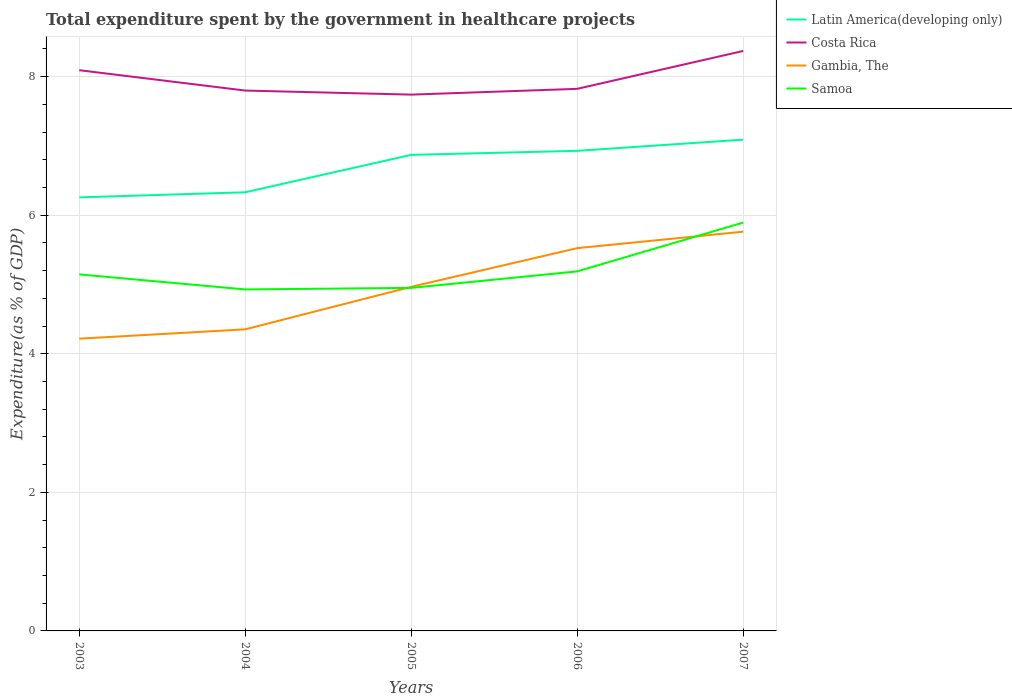Does the line corresponding to Samoa intersect with the line corresponding to Costa Rica?
Provide a succinct answer. No. Across all years, what is the maximum total expenditure spent by the government in healthcare projects in Latin America(developing only)?
Offer a terse response. 6.26. What is the total total expenditure spent by the government in healthcare projects in Gambia, The in the graph?
Keep it short and to the point. -1.54. What is the difference between the highest and the second highest total expenditure spent by the government in healthcare projects in Costa Rica?
Your answer should be compact. 0.63. Is the total expenditure spent by the government in healthcare projects in Gambia, The strictly greater than the total expenditure spent by the government in healthcare projects in Latin America(developing only) over the years?
Provide a succinct answer. Yes. How many lines are there?
Your response must be concise. 4. What is the difference between two consecutive major ticks on the Y-axis?
Ensure brevity in your answer.  2. Does the graph contain any zero values?
Keep it short and to the point. No. How many legend labels are there?
Keep it short and to the point. 4. How are the legend labels stacked?
Your response must be concise. Vertical. What is the title of the graph?
Offer a very short reply. Total expenditure spent by the government in healthcare projects. What is the label or title of the X-axis?
Offer a very short reply. Years. What is the label or title of the Y-axis?
Offer a terse response. Expenditure(as % of GDP). What is the Expenditure(as % of GDP) of Latin America(developing only) in 2003?
Make the answer very short. 6.26. What is the Expenditure(as % of GDP) in Costa Rica in 2003?
Provide a succinct answer. 8.09. What is the Expenditure(as % of GDP) of Gambia, The in 2003?
Ensure brevity in your answer.  4.22. What is the Expenditure(as % of GDP) in Samoa in 2003?
Keep it short and to the point. 5.15. What is the Expenditure(as % of GDP) of Latin America(developing only) in 2004?
Provide a succinct answer. 6.33. What is the Expenditure(as % of GDP) of Costa Rica in 2004?
Offer a very short reply. 7.8. What is the Expenditure(as % of GDP) in Gambia, The in 2004?
Your answer should be very brief. 4.35. What is the Expenditure(as % of GDP) of Samoa in 2004?
Keep it short and to the point. 4.93. What is the Expenditure(as % of GDP) in Latin America(developing only) in 2005?
Your answer should be compact. 6.87. What is the Expenditure(as % of GDP) in Costa Rica in 2005?
Offer a very short reply. 7.74. What is the Expenditure(as % of GDP) of Gambia, The in 2005?
Provide a succinct answer. 4.97. What is the Expenditure(as % of GDP) of Samoa in 2005?
Keep it short and to the point. 4.95. What is the Expenditure(as % of GDP) of Latin America(developing only) in 2006?
Offer a terse response. 6.93. What is the Expenditure(as % of GDP) in Costa Rica in 2006?
Offer a terse response. 7.82. What is the Expenditure(as % of GDP) in Gambia, The in 2006?
Offer a terse response. 5.52. What is the Expenditure(as % of GDP) in Samoa in 2006?
Your answer should be compact. 5.19. What is the Expenditure(as % of GDP) in Latin America(developing only) in 2007?
Keep it short and to the point. 7.09. What is the Expenditure(as % of GDP) in Costa Rica in 2007?
Your response must be concise. 8.37. What is the Expenditure(as % of GDP) in Gambia, The in 2007?
Offer a very short reply. 5.76. What is the Expenditure(as % of GDP) in Samoa in 2007?
Offer a terse response. 5.89. Across all years, what is the maximum Expenditure(as % of GDP) of Latin America(developing only)?
Make the answer very short. 7.09. Across all years, what is the maximum Expenditure(as % of GDP) of Costa Rica?
Offer a very short reply. 8.37. Across all years, what is the maximum Expenditure(as % of GDP) in Gambia, The?
Offer a terse response. 5.76. Across all years, what is the maximum Expenditure(as % of GDP) of Samoa?
Your response must be concise. 5.89. Across all years, what is the minimum Expenditure(as % of GDP) in Latin America(developing only)?
Your answer should be compact. 6.26. Across all years, what is the minimum Expenditure(as % of GDP) of Costa Rica?
Provide a short and direct response. 7.74. Across all years, what is the minimum Expenditure(as % of GDP) of Gambia, The?
Offer a very short reply. 4.22. Across all years, what is the minimum Expenditure(as % of GDP) in Samoa?
Make the answer very short. 4.93. What is the total Expenditure(as % of GDP) of Latin America(developing only) in the graph?
Offer a very short reply. 33.48. What is the total Expenditure(as % of GDP) in Costa Rica in the graph?
Your answer should be very brief. 39.82. What is the total Expenditure(as % of GDP) in Gambia, The in the graph?
Make the answer very short. 24.82. What is the total Expenditure(as % of GDP) of Samoa in the graph?
Offer a very short reply. 26.11. What is the difference between the Expenditure(as % of GDP) of Latin America(developing only) in 2003 and that in 2004?
Offer a terse response. -0.07. What is the difference between the Expenditure(as % of GDP) of Costa Rica in 2003 and that in 2004?
Your answer should be compact. 0.29. What is the difference between the Expenditure(as % of GDP) in Gambia, The in 2003 and that in 2004?
Give a very brief answer. -0.13. What is the difference between the Expenditure(as % of GDP) in Samoa in 2003 and that in 2004?
Your answer should be compact. 0.22. What is the difference between the Expenditure(as % of GDP) of Latin America(developing only) in 2003 and that in 2005?
Your answer should be very brief. -0.61. What is the difference between the Expenditure(as % of GDP) of Costa Rica in 2003 and that in 2005?
Your response must be concise. 0.35. What is the difference between the Expenditure(as % of GDP) in Gambia, The in 2003 and that in 2005?
Ensure brevity in your answer.  -0.75. What is the difference between the Expenditure(as % of GDP) in Samoa in 2003 and that in 2005?
Your answer should be very brief. 0.19. What is the difference between the Expenditure(as % of GDP) of Latin America(developing only) in 2003 and that in 2006?
Your answer should be compact. -0.67. What is the difference between the Expenditure(as % of GDP) of Costa Rica in 2003 and that in 2006?
Your answer should be compact. 0.27. What is the difference between the Expenditure(as % of GDP) in Gambia, The in 2003 and that in 2006?
Offer a very short reply. -1.31. What is the difference between the Expenditure(as % of GDP) in Samoa in 2003 and that in 2006?
Your answer should be compact. -0.04. What is the difference between the Expenditure(as % of GDP) of Latin America(developing only) in 2003 and that in 2007?
Provide a succinct answer. -0.83. What is the difference between the Expenditure(as % of GDP) of Costa Rica in 2003 and that in 2007?
Ensure brevity in your answer.  -0.28. What is the difference between the Expenditure(as % of GDP) in Gambia, The in 2003 and that in 2007?
Offer a very short reply. -1.54. What is the difference between the Expenditure(as % of GDP) of Samoa in 2003 and that in 2007?
Give a very brief answer. -0.75. What is the difference between the Expenditure(as % of GDP) of Latin America(developing only) in 2004 and that in 2005?
Provide a short and direct response. -0.54. What is the difference between the Expenditure(as % of GDP) in Costa Rica in 2004 and that in 2005?
Your response must be concise. 0.06. What is the difference between the Expenditure(as % of GDP) in Gambia, The in 2004 and that in 2005?
Offer a very short reply. -0.61. What is the difference between the Expenditure(as % of GDP) in Samoa in 2004 and that in 2005?
Make the answer very short. -0.02. What is the difference between the Expenditure(as % of GDP) of Latin America(developing only) in 2004 and that in 2006?
Your answer should be very brief. -0.6. What is the difference between the Expenditure(as % of GDP) of Costa Rica in 2004 and that in 2006?
Give a very brief answer. -0.02. What is the difference between the Expenditure(as % of GDP) of Gambia, The in 2004 and that in 2006?
Keep it short and to the point. -1.17. What is the difference between the Expenditure(as % of GDP) of Samoa in 2004 and that in 2006?
Your response must be concise. -0.26. What is the difference between the Expenditure(as % of GDP) of Latin America(developing only) in 2004 and that in 2007?
Give a very brief answer. -0.76. What is the difference between the Expenditure(as % of GDP) in Costa Rica in 2004 and that in 2007?
Provide a short and direct response. -0.57. What is the difference between the Expenditure(as % of GDP) in Gambia, The in 2004 and that in 2007?
Offer a terse response. -1.41. What is the difference between the Expenditure(as % of GDP) in Samoa in 2004 and that in 2007?
Make the answer very short. -0.96. What is the difference between the Expenditure(as % of GDP) of Latin America(developing only) in 2005 and that in 2006?
Your answer should be very brief. -0.06. What is the difference between the Expenditure(as % of GDP) in Costa Rica in 2005 and that in 2006?
Your answer should be very brief. -0.08. What is the difference between the Expenditure(as % of GDP) of Gambia, The in 2005 and that in 2006?
Provide a short and direct response. -0.56. What is the difference between the Expenditure(as % of GDP) of Samoa in 2005 and that in 2006?
Make the answer very short. -0.24. What is the difference between the Expenditure(as % of GDP) of Latin America(developing only) in 2005 and that in 2007?
Your response must be concise. -0.22. What is the difference between the Expenditure(as % of GDP) in Costa Rica in 2005 and that in 2007?
Offer a very short reply. -0.63. What is the difference between the Expenditure(as % of GDP) of Gambia, The in 2005 and that in 2007?
Your answer should be very brief. -0.8. What is the difference between the Expenditure(as % of GDP) of Samoa in 2005 and that in 2007?
Offer a terse response. -0.94. What is the difference between the Expenditure(as % of GDP) of Latin America(developing only) in 2006 and that in 2007?
Offer a terse response. -0.16. What is the difference between the Expenditure(as % of GDP) of Costa Rica in 2006 and that in 2007?
Your response must be concise. -0.55. What is the difference between the Expenditure(as % of GDP) in Gambia, The in 2006 and that in 2007?
Ensure brevity in your answer.  -0.24. What is the difference between the Expenditure(as % of GDP) in Samoa in 2006 and that in 2007?
Ensure brevity in your answer.  -0.7. What is the difference between the Expenditure(as % of GDP) of Latin America(developing only) in 2003 and the Expenditure(as % of GDP) of Costa Rica in 2004?
Your answer should be compact. -1.54. What is the difference between the Expenditure(as % of GDP) in Latin America(developing only) in 2003 and the Expenditure(as % of GDP) in Gambia, The in 2004?
Your answer should be compact. 1.9. What is the difference between the Expenditure(as % of GDP) in Latin America(developing only) in 2003 and the Expenditure(as % of GDP) in Samoa in 2004?
Make the answer very short. 1.33. What is the difference between the Expenditure(as % of GDP) in Costa Rica in 2003 and the Expenditure(as % of GDP) in Gambia, The in 2004?
Keep it short and to the point. 3.74. What is the difference between the Expenditure(as % of GDP) in Costa Rica in 2003 and the Expenditure(as % of GDP) in Samoa in 2004?
Your answer should be very brief. 3.16. What is the difference between the Expenditure(as % of GDP) in Gambia, The in 2003 and the Expenditure(as % of GDP) in Samoa in 2004?
Keep it short and to the point. -0.71. What is the difference between the Expenditure(as % of GDP) in Latin America(developing only) in 2003 and the Expenditure(as % of GDP) in Costa Rica in 2005?
Offer a very short reply. -1.48. What is the difference between the Expenditure(as % of GDP) of Latin America(developing only) in 2003 and the Expenditure(as % of GDP) of Gambia, The in 2005?
Make the answer very short. 1.29. What is the difference between the Expenditure(as % of GDP) of Latin America(developing only) in 2003 and the Expenditure(as % of GDP) of Samoa in 2005?
Your answer should be compact. 1.31. What is the difference between the Expenditure(as % of GDP) of Costa Rica in 2003 and the Expenditure(as % of GDP) of Gambia, The in 2005?
Make the answer very short. 3.13. What is the difference between the Expenditure(as % of GDP) in Costa Rica in 2003 and the Expenditure(as % of GDP) in Samoa in 2005?
Keep it short and to the point. 3.14. What is the difference between the Expenditure(as % of GDP) in Gambia, The in 2003 and the Expenditure(as % of GDP) in Samoa in 2005?
Provide a short and direct response. -0.73. What is the difference between the Expenditure(as % of GDP) in Latin America(developing only) in 2003 and the Expenditure(as % of GDP) in Costa Rica in 2006?
Give a very brief answer. -1.57. What is the difference between the Expenditure(as % of GDP) of Latin America(developing only) in 2003 and the Expenditure(as % of GDP) of Gambia, The in 2006?
Your answer should be compact. 0.73. What is the difference between the Expenditure(as % of GDP) of Latin America(developing only) in 2003 and the Expenditure(as % of GDP) of Samoa in 2006?
Your answer should be very brief. 1.07. What is the difference between the Expenditure(as % of GDP) in Costa Rica in 2003 and the Expenditure(as % of GDP) in Gambia, The in 2006?
Your answer should be very brief. 2.57. What is the difference between the Expenditure(as % of GDP) in Costa Rica in 2003 and the Expenditure(as % of GDP) in Samoa in 2006?
Your answer should be very brief. 2.9. What is the difference between the Expenditure(as % of GDP) of Gambia, The in 2003 and the Expenditure(as % of GDP) of Samoa in 2006?
Your answer should be very brief. -0.97. What is the difference between the Expenditure(as % of GDP) in Latin America(developing only) in 2003 and the Expenditure(as % of GDP) in Costa Rica in 2007?
Provide a short and direct response. -2.11. What is the difference between the Expenditure(as % of GDP) in Latin America(developing only) in 2003 and the Expenditure(as % of GDP) in Gambia, The in 2007?
Your response must be concise. 0.5. What is the difference between the Expenditure(as % of GDP) in Latin America(developing only) in 2003 and the Expenditure(as % of GDP) in Samoa in 2007?
Your response must be concise. 0.36. What is the difference between the Expenditure(as % of GDP) in Costa Rica in 2003 and the Expenditure(as % of GDP) in Gambia, The in 2007?
Your answer should be very brief. 2.33. What is the difference between the Expenditure(as % of GDP) of Costa Rica in 2003 and the Expenditure(as % of GDP) of Samoa in 2007?
Offer a terse response. 2.2. What is the difference between the Expenditure(as % of GDP) in Gambia, The in 2003 and the Expenditure(as % of GDP) in Samoa in 2007?
Ensure brevity in your answer.  -1.68. What is the difference between the Expenditure(as % of GDP) of Latin America(developing only) in 2004 and the Expenditure(as % of GDP) of Costa Rica in 2005?
Ensure brevity in your answer.  -1.41. What is the difference between the Expenditure(as % of GDP) in Latin America(developing only) in 2004 and the Expenditure(as % of GDP) in Gambia, The in 2005?
Your answer should be very brief. 1.36. What is the difference between the Expenditure(as % of GDP) of Latin America(developing only) in 2004 and the Expenditure(as % of GDP) of Samoa in 2005?
Give a very brief answer. 1.38. What is the difference between the Expenditure(as % of GDP) in Costa Rica in 2004 and the Expenditure(as % of GDP) in Gambia, The in 2005?
Provide a succinct answer. 2.83. What is the difference between the Expenditure(as % of GDP) of Costa Rica in 2004 and the Expenditure(as % of GDP) of Samoa in 2005?
Ensure brevity in your answer.  2.85. What is the difference between the Expenditure(as % of GDP) in Gambia, The in 2004 and the Expenditure(as % of GDP) in Samoa in 2005?
Offer a terse response. -0.6. What is the difference between the Expenditure(as % of GDP) of Latin America(developing only) in 2004 and the Expenditure(as % of GDP) of Costa Rica in 2006?
Your answer should be very brief. -1.49. What is the difference between the Expenditure(as % of GDP) of Latin America(developing only) in 2004 and the Expenditure(as % of GDP) of Gambia, The in 2006?
Offer a very short reply. 0.81. What is the difference between the Expenditure(as % of GDP) in Latin America(developing only) in 2004 and the Expenditure(as % of GDP) in Samoa in 2006?
Your answer should be compact. 1.14. What is the difference between the Expenditure(as % of GDP) of Costa Rica in 2004 and the Expenditure(as % of GDP) of Gambia, The in 2006?
Provide a short and direct response. 2.27. What is the difference between the Expenditure(as % of GDP) in Costa Rica in 2004 and the Expenditure(as % of GDP) in Samoa in 2006?
Offer a very short reply. 2.61. What is the difference between the Expenditure(as % of GDP) in Gambia, The in 2004 and the Expenditure(as % of GDP) in Samoa in 2006?
Provide a short and direct response. -0.84. What is the difference between the Expenditure(as % of GDP) of Latin America(developing only) in 2004 and the Expenditure(as % of GDP) of Costa Rica in 2007?
Ensure brevity in your answer.  -2.04. What is the difference between the Expenditure(as % of GDP) of Latin America(developing only) in 2004 and the Expenditure(as % of GDP) of Gambia, The in 2007?
Offer a terse response. 0.57. What is the difference between the Expenditure(as % of GDP) in Latin America(developing only) in 2004 and the Expenditure(as % of GDP) in Samoa in 2007?
Your answer should be compact. 0.44. What is the difference between the Expenditure(as % of GDP) in Costa Rica in 2004 and the Expenditure(as % of GDP) in Gambia, The in 2007?
Your answer should be compact. 2.04. What is the difference between the Expenditure(as % of GDP) in Costa Rica in 2004 and the Expenditure(as % of GDP) in Samoa in 2007?
Your answer should be very brief. 1.91. What is the difference between the Expenditure(as % of GDP) of Gambia, The in 2004 and the Expenditure(as % of GDP) of Samoa in 2007?
Ensure brevity in your answer.  -1.54. What is the difference between the Expenditure(as % of GDP) of Latin America(developing only) in 2005 and the Expenditure(as % of GDP) of Costa Rica in 2006?
Offer a very short reply. -0.95. What is the difference between the Expenditure(as % of GDP) in Latin America(developing only) in 2005 and the Expenditure(as % of GDP) in Gambia, The in 2006?
Offer a very short reply. 1.35. What is the difference between the Expenditure(as % of GDP) of Latin America(developing only) in 2005 and the Expenditure(as % of GDP) of Samoa in 2006?
Your response must be concise. 1.68. What is the difference between the Expenditure(as % of GDP) of Costa Rica in 2005 and the Expenditure(as % of GDP) of Gambia, The in 2006?
Give a very brief answer. 2.22. What is the difference between the Expenditure(as % of GDP) of Costa Rica in 2005 and the Expenditure(as % of GDP) of Samoa in 2006?
Offer a very short reply. 2.55. What is the difference between the Expenditure(as % of GDP) in Gambia, The in 2005 and the Expenditure(as % of GDP) in Samoa in 2006?
Your answer should be very brief. -0.22. What is the difference between the Expenditure(as % of GDP) in Latin America(developing only) in 2005 and the Expenditure(as % of GDP) in Costa Rica in 2007?
Keep it short and to the point. -1.5. What is the difference between the Expenditure(as % of GDP) of Latin America(developing only) in 2005 and the Expenditure(as % of GDP) of Gambia, The in 2007?
Your answer should be very brief. 1.11. What is the difference between the Expenditure(as % of GDP) of Latin America(developing only) in 2005 and the Expenditure(as % of GDP) of Samoa in 2007?
Your response must be concise. 0.98. What is the difference between the Expenditure(as % of GDP) of Costa Rica in 2005 and the Expenditure(as % of GDP) of Gambia, The in 2007?
Give a very brief answer. 1.98. What is the difference between the Expenditure(as % of GDP) of Costa Rica in 2005 and the Expenditure(as % of GDP) of Samoa in 2007?
Make the answer very short. 1.85. What is the difference between the Expenditure(as % of GDP) of Gambia, The in 2005 and the Expenditure(as % of GDP) of Samoa in 2007?
Ensure brevity in your answer.  -0.93. What is the difference between the Expenditure(as % of GDP) of Latin America(developing only) in 2006 and the Expenditure(as % of GDP) of Costa Rica in 2007?
Offer a terse response. -1.44. What is the difference between the Expenditure(as % of GDP) in Latin America(developing only) in 2006 and the Expenditure(as % of GDP) in Samoa in 2007?
Keep it short and to the point. 1.04. What is the difference between the Expenditure(as % of GDP) in Costa Rica in 2006 and the Expenditure(as % of GDP) in Gambia, The in 2007?
Your answer should be compact. 2.06. What is the difference between the Expenditure(as % of GDP) in Costa Rica in 2006 and the Expenditure(as % of GDP) in Samoa in 2007?
Give a very brief answer. 1.93. What is the difference between the Expenditure(as % of GDP) in Gambia, The in 2006 and the Expenditure(as % of GDP) in Samoa in 2007?
Ensure brevity in your answer.  -0.37. What is the average Expenditure(as % of GDP) in Latin America(developing only) per year?
Give a very brief answer. 6.7. What is the average Expenditure(as % of GDP) in Costa Rica per year?
Provide a short and direct response. 7.96. What is the average Expenditure(as % of GDP) of Gambia, The per year?
Offer a very short reply. 4.96. What is the average Expenditure(as % of GDP) in Samoa per year?
Keep it short and to the point. 5.22. In the year 2003, what is the difference between the Expenditure(as % of GDP) of Latin America(developing only) and Expenditure(as % of GDP) of Costa Rica?
Make the answer very short. -1.84. In the year 2003, what is the difference between the Expenditure(as % of GDP) of Latin America(developing only) and Expenditure(as % of GDP) of Gambia, The?
Keep it short and to the point. 2.04. In the year 2003, what is the difference between the Expenditure(as % of GDP) of Latin America(developing only) and Expenditure(as % of GDP) of Samoa?
Offer a very short reply. 1.11. In the year 2003, what is the difference between the Expenditure(as % of GDP) of Costa Rica and Expenditure(as % of GDP) of Gambia, The?
Your answer should be compact. 3.87. In the year 2003, what is the difference between the Expenditure(as % of GDP) in Costa Rica and Expenditure(as % of GDP) in Samoa?
Your answer should be very brief. 2.95. In the year 2003, what is the difference between the Expenditure(as % of GDP) in Gambia, The and Expenditure(as % of GDP) in Samoa?
Give a very brief answer. -0.93. In the year 2004, what is the difference between the Expenditure(as % of GDP) in Latin America(developing only) and Expenditure(as % of GDP) in Costa Rica?
Provide a short and direct response. -1.47. In the year 2004, what is the difference between the Expenditure(as % of GDP) of Latin America(developing only) and Expenditure(as % of GDP) of Gambia, The?
Make the answer very short. 1.98. In the year 2004, what is the difference between the Expenditure(as % of GDP) in Latin America(developing only) and Expenditure(as % of GDP) in Samoa?
Provide a short and direct response. 1.4. In the year 2004, what is the difference between the Expenditure(as % of GDP) in Costa Rica and Expenditure(as % of GDP) in Gambia, The?
Offer a very short reply. 3.45. In the year 2004, what is the difference between the Expenditure(as % of GDP) in Costa Rica and Expenditure(as % of GDP) in Samoa?
Keep it short and to the point. 2.87. In the year 2004, what is the difference between the Expenditure(as % of GDP) of Gambia, The and Expenditure(as % of GDP) of Samoa?
Keep it short and to the point. -0.58. In the year 2005, what is the difference between the Expenditure(as % of GDP) of Latin America(developing only) and Expenditure(as % of GDP) of Costa Rica?
Provide a short and direct response. -0.87. In the year 2005, what is the difference between the Expenditure(as % of GDP) in Latin America(developing only) and Expenditure(as % of GDP) in Gambia, The?
Ensure brevity in your answer.  1.9. In the year 2005, what is the difference between the Expenditure(as % of GDP) of Latin America(developing only) and Expenditure(as % of GDP) of Samoa?
Keep it short and to the point. 1.92. In the year 2005, what is the difference between the Expenditure(as % of GDP) of Costa Rica and Expenditure(as % of GDP) of Gambia, The?
Your answer should be compact. 2.77. In the year 2005, what is the difference between the Expenditure(as % of GDP) of Costa Rica and Expenditure(as % of GDP) of Samoa?
Your answer should be compact. 2.79. In the year 2005, what is the difference between the Expenditure(as % of GDP) in Gambia, The and Expenditure(as % of GDP) in Samoa?
Your answer should be compact. 0.02. In the year 2006, what is the difference between the Expenditure(as % of GDP) of Latin America(developing only) and Expenditure(as % of GDP) of Costa Rica?
Your response must be concise. -0.89. In the year 2006, what is the difference between the Expenditure(as % of GDP) of Latin America(developing only) and Expenditure(as % of GDP) of Gambia, The?
Offer a terse response. 1.4. In the year 2006, what is the difference between the Expenditure(as % of GDP) of Latin America(developing only) and Expenditure(as % of GDP) of Samoa?
Provide a succinct answer. 1.74. In the year 2006, what is the difference between the Expenditure(as % of GDP) in Costa Rica and Expenditure(as % of GDP) in Gambia, The?
Provide a succinct answer. 2.3. In the year 2006, what is the difference between the Expenditure(as % of GDP) of Costa Rica and Expenditure(as % of GDP) of Samoa?
Provide a short and direct response. 2.63. In the year 2006, what is the difference between the Expenditure(as % of GDP) in Gambia, The and Expenditure(as % of GDP) in Samoa?
Provide a succinct answer. 0.34. In the year 2007, what is the difference between the Expenditure(as % of GDP) in Latin America(developing only) and Expenditure(as % of GDP) in Costa Rica?
Your response must be concise. -1.28. In the year 2007, what is the difference between the Expenditure(as % of GDP) in Latin America(developing only) and Expenditure(as % of GDP) in Gambia, The?
Keep it short and to the point. 1.33. In the year 2007, what is the difference between the Expenditure(as % of GDP) of Latin America(developing only) and Expenditure(as % of GDP) of Samoa?
Make the answer very short. 1.2. In the year 2007, what is the difference between the Expenditure(as % of GDP) in Costa Rica and Expenditure(as % of GDP) in Gambia, The?
Give a very brief answer. 2.61. In the year 2007, what is the difference between the Expenditure(as % of GDP) of Costa Rica and Expenditure(as % of GDP) of Samoa?
Make the answer very short. 2.48. In the year 2007, what is the difference between the Expenditure(as % of GDP) in Gambia, The and Expenditure(as % of GDP) in Samoa?
Keep it short and to the point. -0.13. What is the ratio of the Expenditure(as % of GDP) in Latin America(developing only) in 2003 to that in 2004?
Provide a short and direct response. 0.99. What is the ratio of the Expenditure(as % of GDP) in Costa Rica in 2003 to that in 2004?
Your answer should be compact. 1.04. What is the ratio of the Expenditure(as % of GDP) in Gambia, The in 2003 to that in 2004?
Offer a very short reply. 0.97. What is the ratio of the Expenditure(as % of GDP) in Samoa in 2003 to that in 2004?
Ensure brevity in your answer.  1.04. What is the ratio of the Expenditure(as % of GDP) of Latin America(developing only) in 2003 to that in 2005?
Keep it short and to the point. 0.91. What is the ratio of the Expenditure(as % of GDP) in Costa Rica in 2003 to that in 2005?
Provide a succinct answer. 1.05. What is the ratio of the Expenditure(as % of GDP) of Gambia, The in 2003 to that in 2005?
Give a very brief answer. 0.85. What is the ratio of the Expenditure(as % of GDP) of Samoa in 2003 to that in 2005?
Your answer should be compact. 1.04. What is the ratio of the Expenditure(as % of GDP) of Latin America(developing only) in 2003 to that in 2006?
Give a very brief answer. 0.9. What is the ratio of the Expenditure(as % of GDP) in Costa Rica in 2003 to that in 2006?
Ensure brevity in your answer.  1.03. What is the ratio of the Expenditure(as % of GDP) in Gambia, The in 2003 to that in 2006?
Make the answer very short. 0.76. What is the ratio of the Expenditure(as % of GDP) in Latin America(developing only) in 2003 to that in 2007?
Offer a terse response. 0.88. What is the ratio of the Expenditure(as % of GDP) in Costa Rica in 2003 to that in 2007?
Keep it short and to the point. 0.97. What is the ratio of the Expenditure(as % of GDP) in Gambia, The in 2003 to that in 2007?
Provide a succinct answer. 0.73. What is the ratio of the Expenditure(as % of GDP) in Samoa in 2003 to that in 2007?
Give a very brief answer. 0.87. What is the ratio of the Expenditure(as % of GDP) in Latin America(developing only) in 2004 to that in 2005?
Your answer should be compact. 0.92. What is the ratio of the Expenditure(as % of GDP) in Costa Rica in 2004 to that in 2005?
Offer a very short reply. 1.01. What is the ratio of the Expenditure(as % of GDP) of Gambia, The in 2004 to that in 2005?
Ensure brevity in your answer.  0.88. What is the ratio of the Expenditure(as % of GDP) in Samoa in 2004 to that in 2005?
Your answer should be compact. 1. What is the ratio of the Expenditure(as % of GDP) in Latin America(developing only) in 2004 to that in 2006?
Give a very brief answer. 0.91. What is the ratio of the Expenditure(as % of GDP) in Costa Rica in 2004 to that in 2006?
Your answer should be compact. 1. What is the ratio of the Expenditure(as % of GDP) of Gambia, The in 2004 to that in 2006?
Offer a very short reply. 0.79. What is the ratio of the Expenditure(as % of GDP) in Samoa in 2004 to that in 2006?
Offer a terse response. 0.95. What is the ratio of the Expenditure(as % of GDP) of Latin America(developing only) in 2004 to that in 2007?
Your answer should be very brief. 0.89. What is the ratio of the Expenditure(as % of GDP) of Costa Rica in 2004 to that in 2007?
Make the answer very short. 0.93. What is the ratio of the Expenditure(as % of GDP) in Gambia, The in 2004 to that in 2007?
Your answer should be very brief. 0.76. What is the ratio of the Expenditure(as % of GDP) in Samoa in 2004 to that in 2007?
Your answer should be compact. 0.84. What is the ratio of the Expenditure(as % of GDP) in Costa Rica in 2005 to that in 2006?
Your response must be concise. 0.99. What is the ratio of the Expenditure(as % of GDP) in Gambia, The in 2005 to that in 2006?
Provide a succinct answer. 0.9. What is the ratio of the Expenditure(as % of GDP) of Samoa in 2005 to that in 2006?
Ensure brevity in your answer.  0.95. What is the ratio of the Expenditure(as % of GDP) in Latin America(developing only) in 2005 to that in 2007?
Offer a very short reply. 0.97. What is the ratio of the Expenditure(as % of GDP) in Costa Rica in 2005 to that in 2007?
Offer a terse response. 0.92. What is the ratio of the Expenditure(as % of GDP) in Gambia, The in 2005 to that in 2007?
Your answer should be very brief. 0.86. What is the ratio of the Expenditure(as % of GDP) in Samoa in 2005 to that in 2007?
Offer a very short reply. 0.84. What is the ratio of the Expenditure(as % of GDP) of Latin America(developing only) in 2006 to that in 2007?
Ensure brevity in your answer.  0.98. What is the ratio of the Expenditure(as % of GDP) of Costa Rica in 2006 to that in 2007?
Provide a short and direct response. 0.93. What is the ratio of the Expenditure(as % of GDP) of Gambia, The in 2006 to that in 2007?
Keep it short and to the point. 0.96. What is the ratio of the Expenditure(as % of GDP) of Samoa in 2006 to that in 2007?
Ensure brevity in your answer.  0.88. What is the difference between the highest and the second highest Expenditure(as % of GDP) in Latin America(developing only)?
Ensure brevity in your answer.  0.16. What is the difference between the highest and the second highest Expenditure(as % of GDP) of Costa Rica?
Give a very brief answer. 0.28. What is the difference between the highest and the second highest Expenditure(as % of GDP) of Gambia, The?
Provide a short and direct response. 0.24. What is the difference between the highest and the second highest Expenditure(as % of GDP) in Samoa?
Ensure brevity in your answer.  0.7. What is the difference between the highest and the lowest Expenditure(as % of GDP) in Latin America(developing only)?
Your answer should be very brief. 0.83. What is the difference between the highest and the lowest Expenditure(as % of GDP) of Costa Rica?
Make the answer very short. 0.63. What is the difference between the highest and the lowest Expenditure(as % of GDP) in Gambia, The?
Provide a succinct answer. 1.54. What is the difference between the highest and the lowest Expenditure(as % of GDP) of Samoa?
Keep it short and to the point. 0.96. 